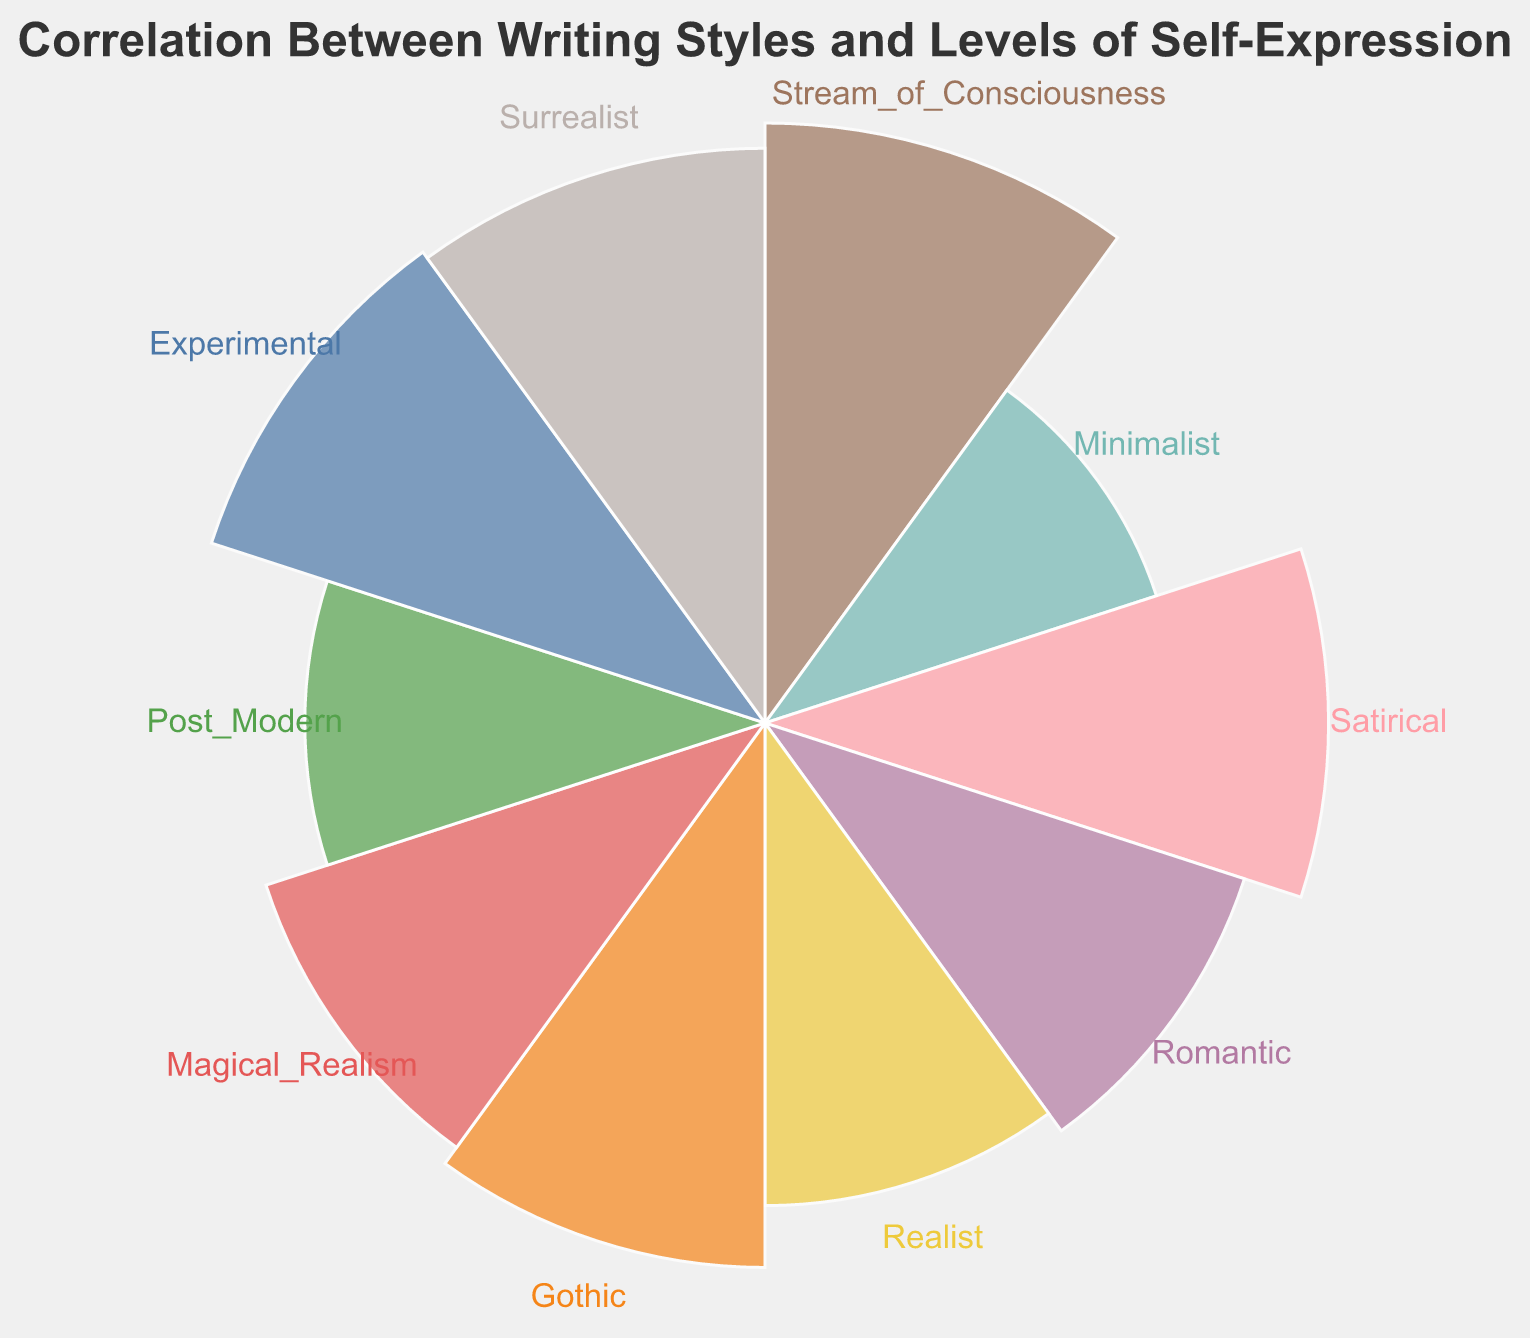What is the highest level of self-expression for any writing style? The highest level of self-expression is found by looking at the data points with the largest radius. The "Stream_of_Consciousness" writing style has the highest self-expression level of 85.
Answer: 85 What writing style has the lowest level of self-expression? The lowest level of self-expression is identified by locating the smallest radius in the chart. The "Minimalist" writing style has the lowest self-expression level of 40.
Answer: Minimalist Which writing styles have a level of self-expression above 70? To find these, we look for all data points with a radius reflecting a value greater than 70. "Stream_of_Consciousness" (85), "Satirical" (75), "Gothic" (70), "Experimental" (80), and "Surrealist" (78) meet this criterion.
Answer: Stream_of_Consciousness, Satirical, Experimental, Surrealist How many writing styles are plotted in the chart? Counting all distinct data points, we see that there are 10 different writing styles represented in the polar chart.
Answer: 10 What is the difference in self-expression levels between the writing styles with the highest and lowest self-expression? The highest level is 85 ("Stream_of_Consciousness") and the lowest is 40 ("Minimalist"). The difference is calculated as 85 - 40.
Answer: 45 What writing styles have a level of self-expression between 55 and 70 inclusive? Examine each data point's radius to see if it falls within this range. The writing styles that fit are "Gothic" (70), "Romantic" (60), "Realist" (55), and "Magical_Realism" (65).
Answer: Gothic, Romantic, Realist, Magical_Realism Which writing style has the third highest level of self-expression? By ranking the levels of self-expression, the third highest is "Surrealist" with a level of 78.
Answer: Surrealist Is the level of self-expression higher for "Romantic" or "Post_Modern" writing style? Comparing the radius values of "Romantic" (60) and "Post_Modern" (50), "Romantic" has the higher level of self-expression.
Answer: Romantic What is the average self-expression level of all writing styles? Adding all the levels of self-expression (85 + 40 + 75 + 60 + 55 + 70 + 65 + 50 + 80 + 78) and then dividing by the number of writing styles (10), we get 658 / 10 = 65.8.
Answer: 65.8 